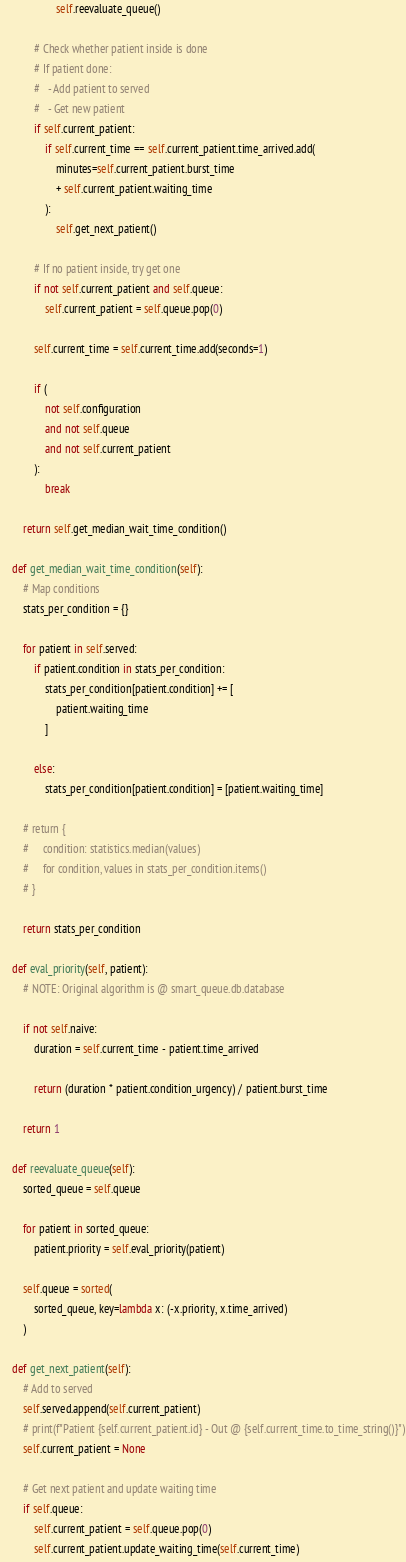<code> <loc_0><loc_0><loc_500><loc_500><_Python_>
                    self.reevaluate_queue()

            # Check whether patient inside is done
            # If patient done:
            #   - Add patient to served
            #   - Get new patient
            if self.current_patient:
                if self.current_time == self.current_patient.time_arrived.add(
                    minutes=self.current_patient.burst_time
                    + self.current_patient.waiting_time
                ):
                    self.get_next_patient()

            # If no patient inside, try get one
            if not self.current_patient and self.queue:
                self.current_patient = self.queue.pop(0)

            self.current_time = self.current_time.add(seconds=1)

            if (
                not self.configuration
                and not self.queue
                and not self.current_patient
            ):
                break

        return self.get_median_wait_time_condition()

    def get_median_wait_time_condition(self):
        # Map conditions
        stats_per_condition = {}

        for patient in self.served:
            if patient.condition in stats_per_condition:
                stats_per_condition[patient.condition] += [
                    patient.waiting_time
                ]

            else:
                stats_per_condition[patient.condition] = [patient.waiting_time]

        # return {
        #     condition: statistics.median(values)
        #     for condition, values in stats_per_condition.items()
        # }

        return stats_per_condition

    def eval_priority(self, patient):
        # NOTE: Original algorithm is @ smart_queue.db.database

        if not self.naive:
            duration = self.current_time - patient.time_arrived

            return (duration * patient.condition_urgency) / patient.burst_time

        return 1

    def reevaluate_queue(self):
        sorted_queue = self.queue

        for patient in sorted_queue:
            patient.priority = self.eval_priority(patient)

        self.queue = sorted(
            sorted_queue, key=lambda x: (-x.priority, x.time_arrived)
        )

    def get_next_patient(self):
        # Add to served
        self.served.append(self.current_patient)
        # print(f"Patient {self.current_patient.id} - Out @ {self.current_time.to_time_string()}")
        self.current_patient = None

        # Get next patient and update waiting time
        if self.queue:
            self.current_patient = self.queue.pop(0)
            self.current_patient.update_waiting_time(self.current_time)</code> 